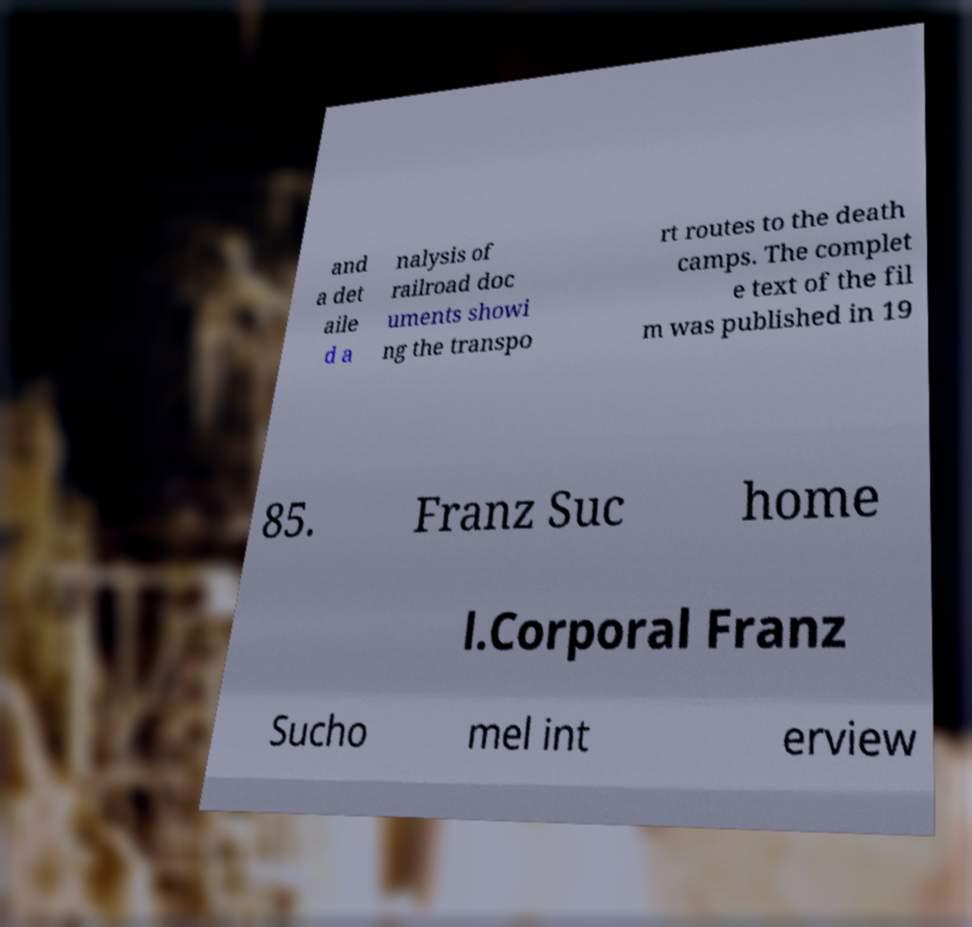Can you accurately transcribe the text from the provided image for me? and a det aile d a nalysis of railroad doc uments showi ng the transpo rt routes to the death camps. The complet e text of the fil m was published in 19 85. Franz Suc home l.Corporal Franz Sucho mel int erview 